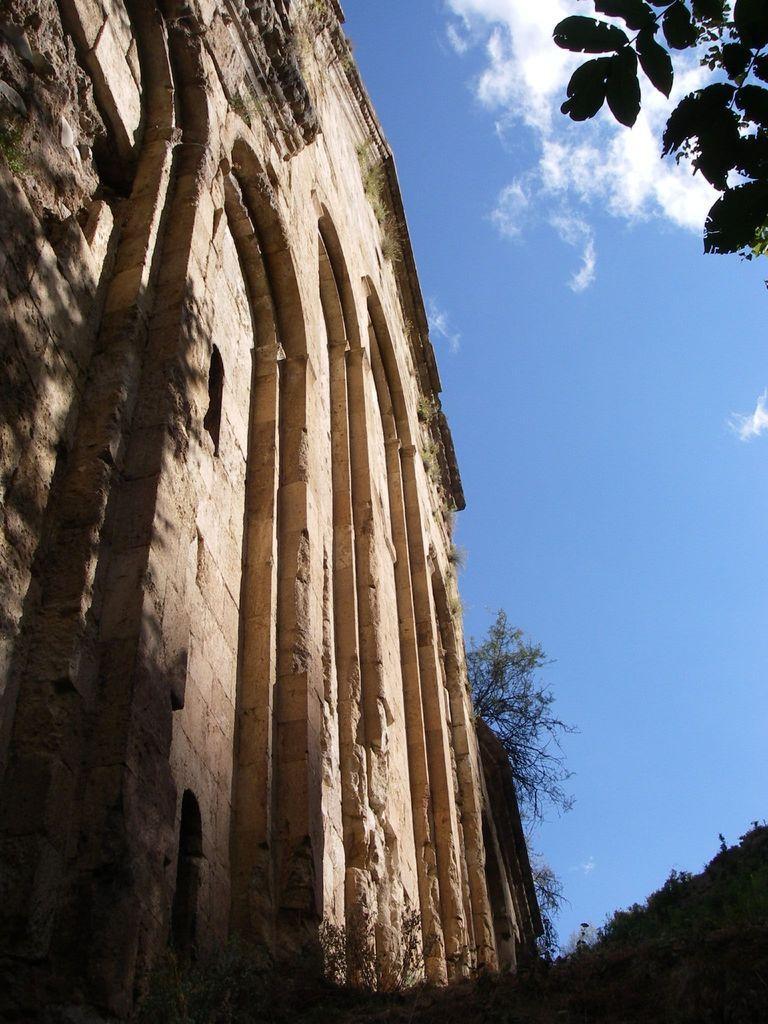Can you describe this image briefly? Here we can see a building and there are trees. In the background there is sky with clouds. 